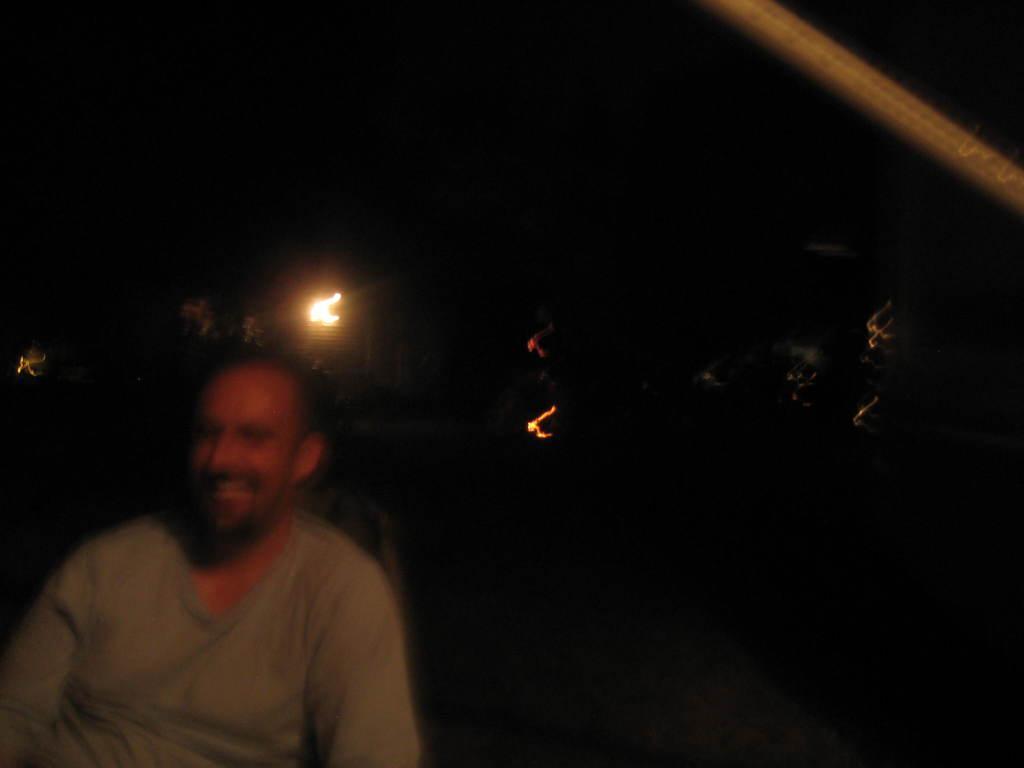Please provide a concise description of this image. In this image in the foreground there are two persons who are sitting, and in the background there are some lights and trees. On the top of the image there is one pole. 